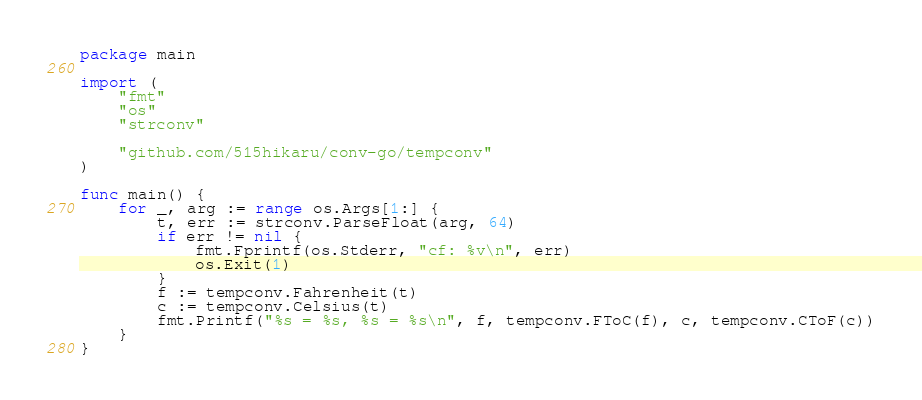Convert code to text. <code><loc_0><loc_0><loc_500><loc_500><_Go_>package main

import (
	"fmt"
	"os"
	"strconv"

	"github.com/515hikaru/conv-go/tempconv"
)

func main() {
	for _, arg := range os.Args[1:] {
		t, err := strconv.ParseFloat(arg, 64)
		if err != nil {
			fmt.Fprintf(os.Stderr, "cf: %v\n", err)
			os.Exit(1)
		}
		f := tempconv.Fahrenheit(t)
		c := tempconv.Celsius(t)
		fmt.Printf("%s = %s, %s = %s\n", f, tempconv.FToC(f), c, tempconv.CToF(c))
	}
}
</code> 